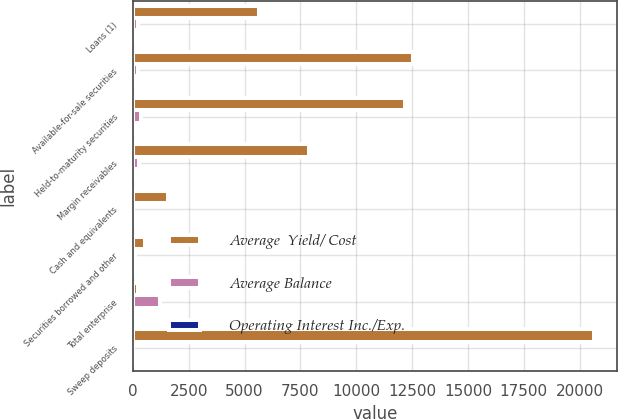Convert chart. <chart><loc_0><loc_0><loc_500><loc_500><stacked_bar_chart><ecel><fcel>Loans (1)<fcel>Available-for-sale securities<fcel>Held-to-maturity securities<fcel>Margin receivables<fcel>Cash and equivalents<fcel>Securities borrowed and other<fcel>Total enterprise<fcel>Sweep deposits<nl><fcel>Average  Yield/ Cost<fcel>5651<fcel>12541<fcel>12201<fcel>7884<fcel>1572<fcel>527<fcel>230<fcel>20638<nl><fcel>Average Balance<fcel>230<fcel>245<fcel>346<fcel>276<fcel>3<fcel>115<fcel>1216<fcel>4<nl><fcel>Operating Interest Inc./Exp.<fcel>4.06<fcel>1.95<fcel>2.84<fcel>3.5<fcel>0.19<fcel>21.9<fcel>2.98<fcel>0.02<nl></chart> 